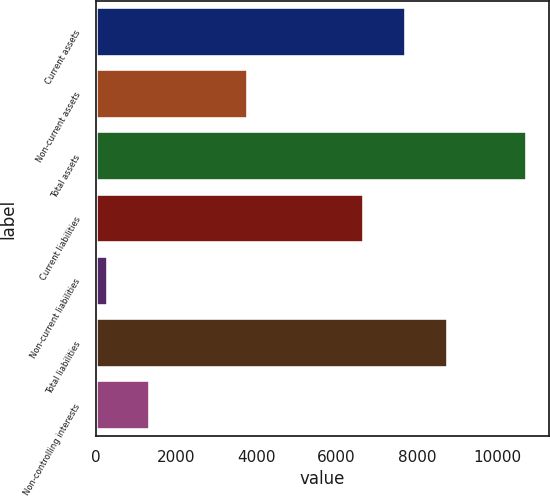Convert chart to OTSL. <chart><loc_0><loc_0><loc_500><loc_500><bar_chart><fcel>Current assets<fcel>Non-current assets<fcel>Total assets<fcel>Current liabilities<fcel>Non-current liabilities<fcel>Total liabilities<fcel>Non-controlling interests<nl><fcel>7739.6<fcel>3794<fcel>10748<fcel>6695<fcel>302<fcel>8784.2<fcel>1346.6<nl></chart> 